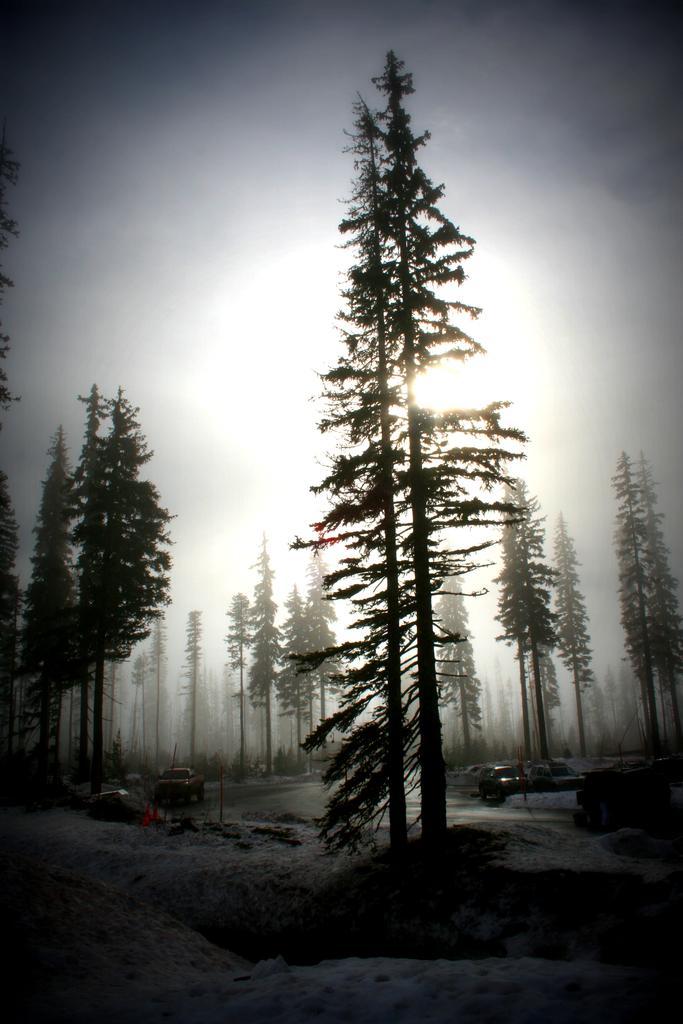Could you give a brief overview of what you see in this image? In this image, we can see some trees and cars. In the background, we can see the sky. 